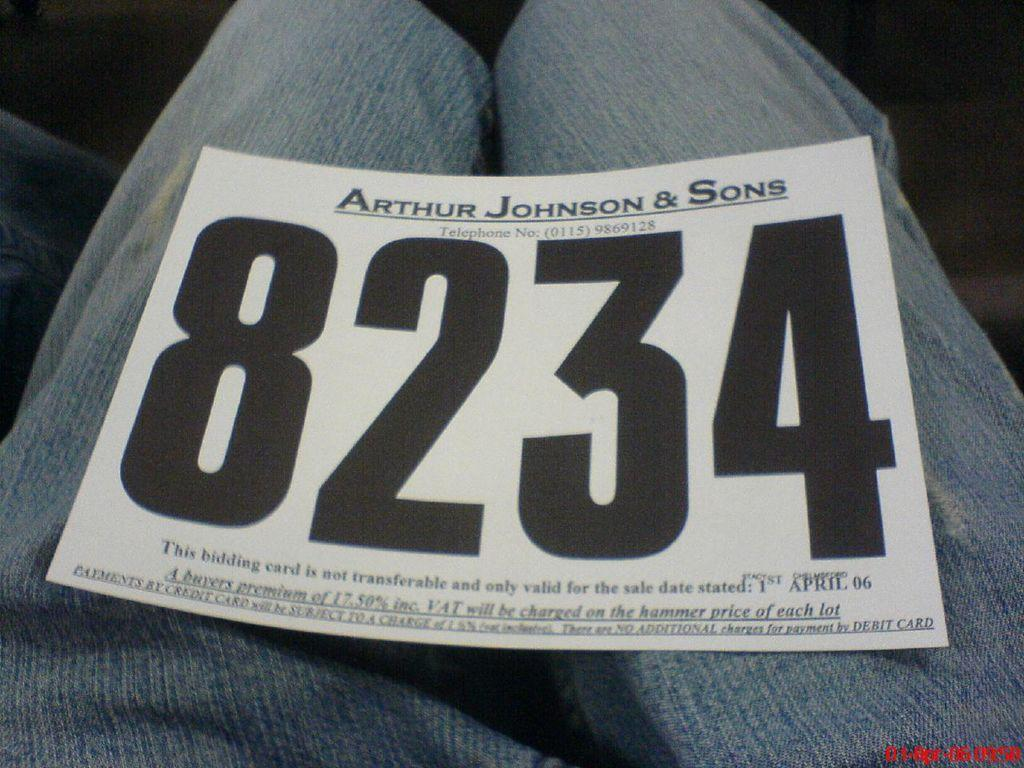What is present in the image? There is a paper in the image. What can be observed on the paper? Some matter is written on the paper. What type of pies are being served during the holiday depicted in the image? There is no holiday or pies present in the image; it only features a paper with writing on it. 